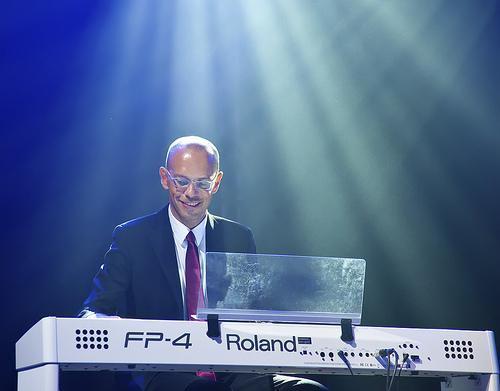How many pianos?
Give a very brief answer. 1. 